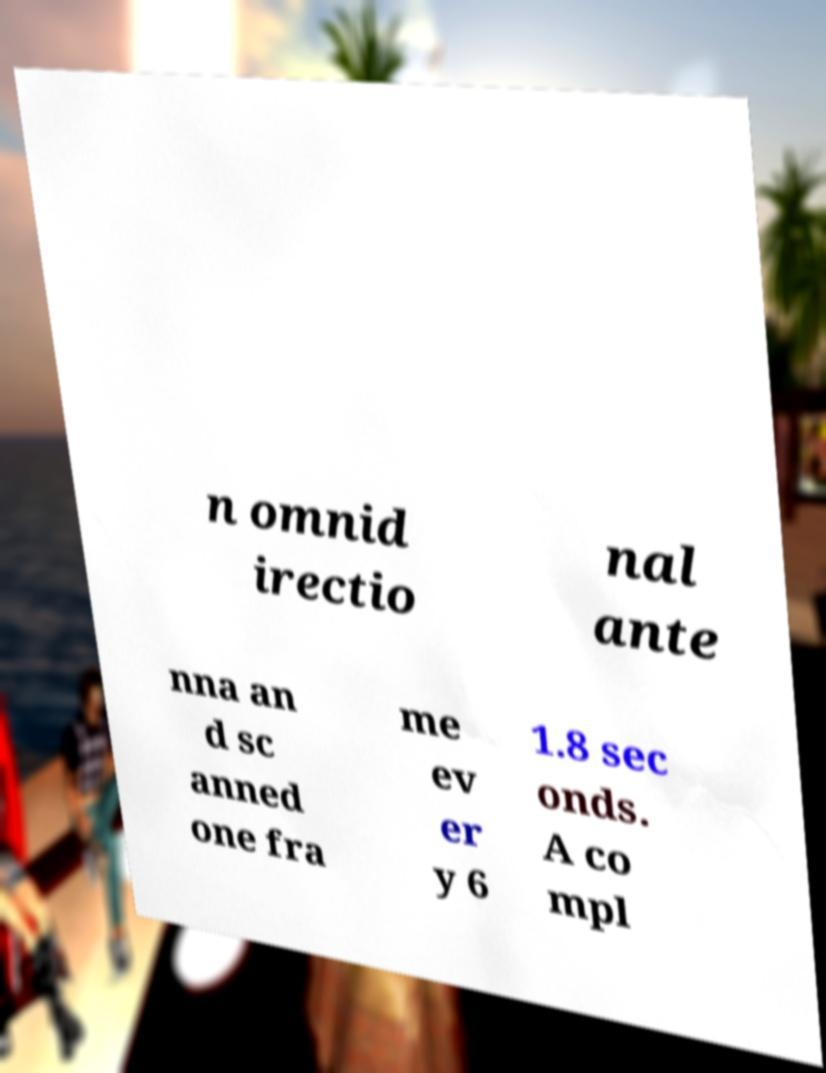I need the written content from this picture converted into text. Can you do that? n omnid irectio nal ante nna an d sc anned one fra me ev er y 6 1.8 sec onds. A co mpl 